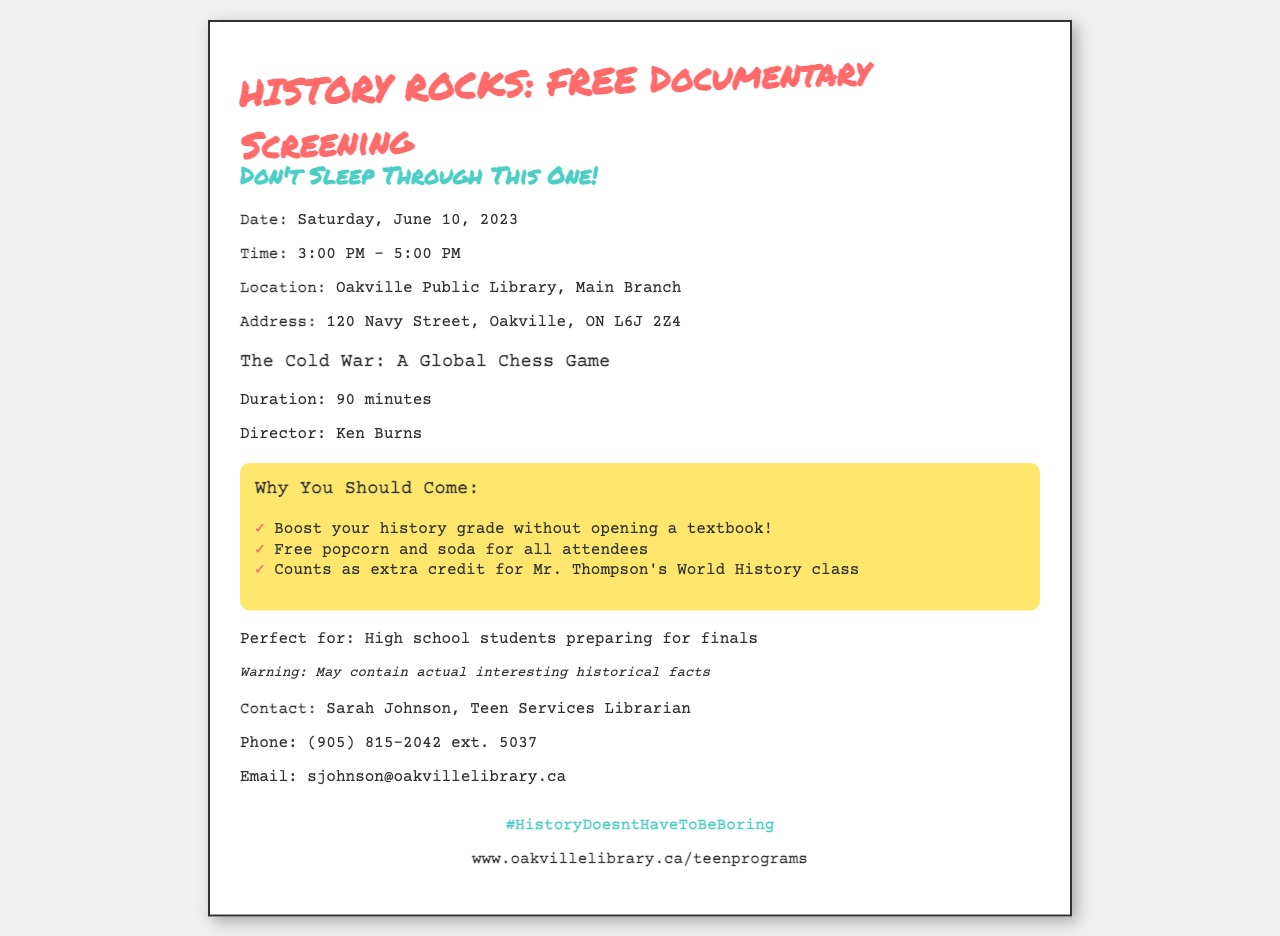What is the date of the screening? The date of the screening is explicitly stated in the event details section.
Answer: Saturday, June 10, 2023 What time does the documentary start? The start time is listed in the event details section.
Answer: 3:00 PM What is the name of the documentary being screened? The title of the documentary is highlighted in the documentary info section.
Answer: The Cold War: A Global Chess Game Who is the director of the documentary? The director's name is provided in the documentary info section.
Answer: Ken Burns What location is hosting the event? The location of the event is detailed in the event details section.
Answer: Oakville Public Library, Main Branch Why might high school students want to attend this event? The reasons for attending are outlined in the selling points section, specifically targeting students.
Answer: Counts as extra credit for Mr. Thompson's World History class What is one of the perks of attending the screening? The perks are specified in the selling points section and are aimed at enticing attendees.
Answer: Free popcorn and soda for all attendees Who can be contacted for more information? The contact person is detailed in the contact section, providing their role and name.
Answer: Sarah Johnson What is the disclaimer about the documentary's content? The disclaimer warns attendees about the nature of the documentary, highlighting its content.
Answer: May contain actual interesting historical facts 